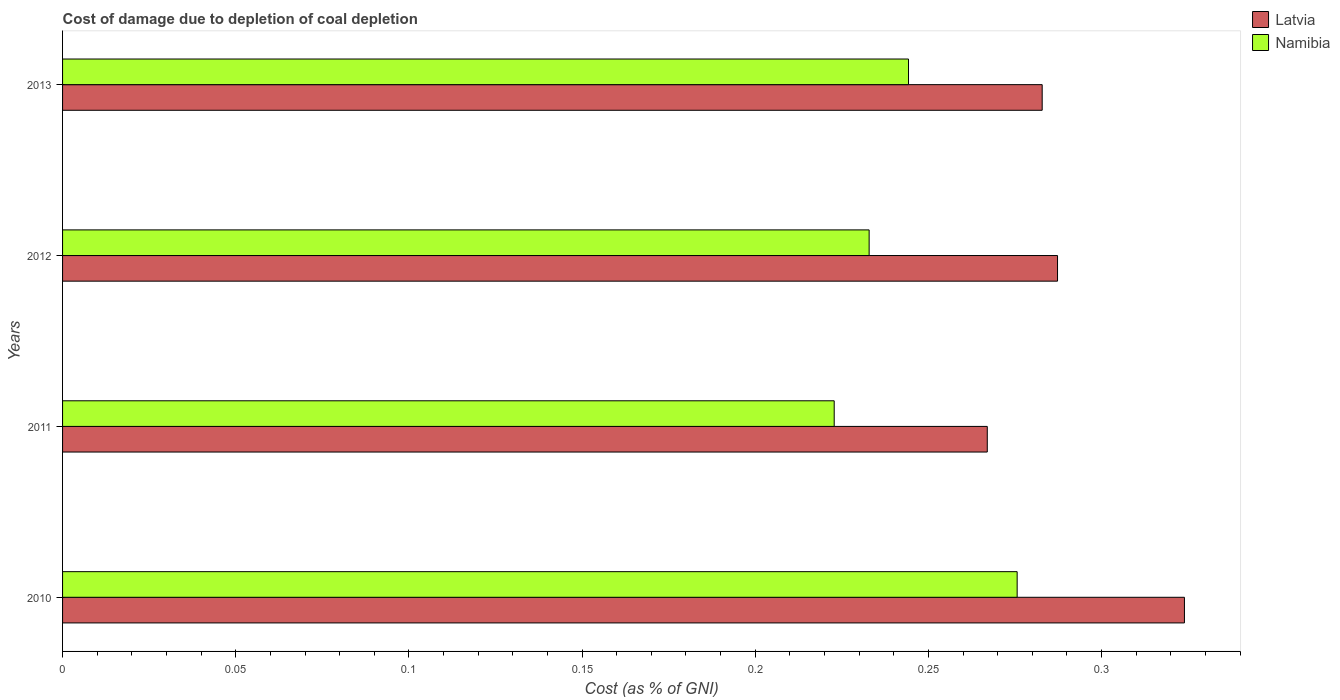How many groups of bars are there?
Your answer should be very brief. 4. Are the number of bars per tick equal to the number of legend labels?
Offer a very short reply. Yes. Are the number of bars on each tick of the Y-axis equal?
Keep it short and to the point. Yes. How many bars are there on the 3rd tick from the bottom?
Your answer should be compact. 2. What is the label of the 2nd group of bars from the top?
Your response must be concise. 2012. What is the cost of damage caused due to coal depletion in Latvia in 2011?
Make the answer very short. 0.27. Across all years, what is the maximum cost of damage caused due to coal depletion in Namibia?
Provide a short and direct response. 0.28. Across all years, what is the minimum cost of damage caused due to coal depletion in Latvia?
Your answer should be compact. 0.27. In which year was the cost of damage caused due to coal depletion in Latvia minimum?
Make the answer very short. 2011. What is the total cost of damage caused due to coal depletion in Namibia in the graph?
Provide a succinct answer. 0.98. What is the difference between the cost of damage caused due to coal depletion in Namibia in 2012 and that in 2013?
Offer a terse response. -0.01. What is the difference between the cost of damage caused due to coal depletion in Latvia in 2013 and the cost of damage caused due to coal depletion in Namibia in 2012?
Provide a succinct answer. 0.05. What is the average cost of damage caused due to coal depletion in Namibia per year?
Give a very brief answer. 0.24. In the year 2013, what is the difference between the cost of damage caused due to coal depletion in Latvia and cost of damage caused due to coal depletion in Namibia?
Your response must be concise. 0.04. In how many years, is the cost of damage caused due to coal depletion in Namibia greater than 0.16000000000000003 %?
Offer a very short reply. 4. What is the ratio of the cost of damage caused due to coal depletion in Latvia in 2012 to that in 2013?
Keep it short and to the point. 1.02. Is the difference between the cost of damage caused due to coal depletion in Latvia in 2012 and 2013 greater than the difference between the cost of damage caused due to coal depletion in Namibia in 2012 and 2013?
Offer a terse response. Yes. What is the difference between the highest and the second highest cost of damage caused due to coal depletion in Namibia?
Offer a very short reply. 0.03. What is the difference between the highest and the lowest cost of damage caused due to coal depletion in Latvia?
Your answer should be compact. 0.06. In how many years, is the cost of damage caused due to coal depletion in Latvia greater than the average cost of damage caused due to coal depletion in Latvia taken over all years?
Provide a succinct answer. 1. Is the sum of the cost of damage caused due to coal depletion in Namibia in 2010 and 2012 greater than the maximum cost of damage caused due to coal depletion in Latvia across all years?
Offer a very short reply. Yes. What does the 1st bar from the top in 2010 represents?
Give a very brief answer. Namibia. What does the 1st bar from the bottom in 2013 represents?
Ensure brevity in your answer.  Latvia. Are all the bars in the graph horizontal?
Give a very brief answer. Yes. Does the graph contain any zero values?
Provide a succinct answer. No. Where does the legend appear in the graph?
Provide a succinct answer. Top right. How many legend labels are there?
Make the answer very short. 2. How are the legend labels stacked?
Provide a succinct answer. Vertical. What is the title of the graph?
Provide a short and direct response. Cost of damage due to depletion of coal depletion. What is the label or title of the X-axis?
Ensure brevity in your answer.  Cost (as % of GNI). What is the Cost (as % of GNI) in Latvia in 2010?
Provide a succinct answer. 0.32. What is the Cost (as % of GNI) of Namibia in 2010?
Ensure brevity in your answer.  0.28. What is the Cost (as % of GNI) of Latvia in 2011?
Offer a very short reply. 0.27. What is the Cost (as % of GNI) of Namibia in 2011?
Keep it short and to the point. 0.22. What is the Cost (as % of GNI) of Latvia in 2012?
Provide a short and direct response. 0.29. What is the Cost (as % of GNI) of Namibia in 2012?
Give a very brief answer. 0.23. What is the Cost (as % of GNI) of Latvia in 2013?
Your response must be concise. 0.28. What is the Cost (as % of GNI) in Namibia in 2013?
Provide a short and direct response. 0.24. Across all years, what is the maximum Cost (as % of GNI) in Latvia?
Your answer should be very brief. 0.32. Across all years, what is the maximum Cost (as % of GNI) in Namibia?
Keep it short and to the point. 0.28. Across all years, what is the minimum Cost (as % of GNI) of Latvia?
Provide a short and direct response. 0.27. Across all years, what is the minimum Cost (as % of GNI) in Namibia?
Your response must be concise. 0.22. What is the total Cost (as % of GNI) of Latvia in the graph?
Make the answer very short. 1.16. What is the total Cost (as % of GNI) of Namibia in the graph?
Provide a short and direct response. 0.98. What is the difference between the Cost (as % of GNI) in Latvia in 2010 and that in 2011?
Provide a short and direct response. 0.06. What is the difference between the Cost (as % of GNI) in Namibia in 2010 and that in 2011?
Offer a very short reply. 0.05. What is the difference between the Cost (as % of GNI) of Latvia in 2010 and that in 2012?
Ensure brevity in your answer.  0.04. What is the difference between the Cost (as % of GNI) in Namibia in 2010 and that in 2012?
Your response must be concise. 0.04. What is the difference between the Cost (as % of GNI) of Latvia in 2010 and that in 2013?
Your answer should be very brief. 0.04. What is the difference between the Cost (as % of GNI) in Namibia in 2010 and that in 2013?
Your answer should be compact. 0.03. What is the difference between the Cost (as % of GNI) in Latvia in 2011 and that in 2012?
Make the answer very short. -0.02. What is the difference between the Cost (as % of GNI) of Namibia in 2011 and that in 2012?
Your answer should be compact. -0.01. What is the difference between the Cost (as % of GNI) in Latvia in 2011 and that in 2013?
Keep it short and to the point. -0.02. What is the difference between the Cost (as % of GNI) of Namibia in 2011 and that in 2013?
Keep it short and to the point. -0.02. What is the difference between the Cost (as % of GNI) in Latvia in 2012 and that in 2013?
Make the answer very short. 0. What is the difference between the Cost (as % of GNI) of Namibia in 2012 and that in 2013?
Your answer should be compact. -0.01. What is the difference between the Cost (as % of GNI) of Latvia in 2010 and the Cost (as % of GNI) of Namibia in 2011?
Ensure brevity in your answer.  0.1. What is the difference between the Cost (as % of GNI) of Latvia in 2010 and the Cost (as % of GNI) of Namibia in 2012?
Provide a short and direct response. 0.09. What is the difference between the Cost (as % of GNI) of Latvia in 2010 and the Cost (as % of GNI) of Namibia in 2013?
Offer a terse response. 0.08. What is the difference between the Cost (as % of GNI) of Latvia in 2011 and the Cost (as % of GNI) of Namibia in 2012?
Give a very brief answer. 0.03. What is the difference between the Cost (as % of GNI) of Latvia in 2011 and the Cost (as % of GNI) of Namibia in 2013?
Provide a succinct answer. 0.02. What is the difference between the Cost (as % of GNI) in Latvia in 2012 and the Cost (as % of GNI) in Namibia in 2013?
Offer a terse response. 0.04. What is the average Cost (as % of GNI) in Latvia per year?
Ensure brevity in your answer.  0.29. What is the average Cost (as % of GNI) in Namibia per year?
Provide a short and direct response. 0.24. In the year 2010, what is the difference between the Cost (as % of GNI) in Latvia and Cost (as % of GNI) in Namibia?
Provide a short and direct response. 0.05. In the year 2011, what is the difference between the Cost (as % of GNI) in Latvia and Cost (as % of GNI) in Namibia?
Your response must be concise. 0.04. In the year 2012, what is the difference between the Cost (as % of GNI) in Latvia and Cost (as % of GNI) in Namibia?
Offer a terse response. 0.05. In the year 2013, what is the difference between the Cost (as % of GNI) in Latvia and Cost (as % of GNI) in Namibia?
Make the answer very short. 0.04. What is the ratio of the Cost (as % of GNI) in Latvia in 2010 to that in 2011?
Your answer should be very brief. 1.21. What is the ratio of the Cost (as % of GNI) of Namibia in 2010 to that in 2011?
Your response must be concise. 1.24. What is the ratio of the Cost (as % of GNI) of Latvia in 2010 to that in 2012?
Your answer should be compact. 1.13. What is the ratio of the Cost (as % of GNI) of Namibia in 2010 to that in 2012?
Your response must be concise. 1.18. What is the ratio of the Cost (as % of GNI) in Latvia in 2010 to that in 2013?
Keep it short and to the point. 1.15. What is the ratio of the Cost (as % of GNI) in Namibia in 2010 to that in 2013?
Offer a terse response. 1.13. What is the ratio of the Cost (as % of GNI) in Latvia in 2011 to that in 2012?
Offer a very short reply. 0.93. What is the ratio of the Cost (as % of GNI) in Namibia in 2011 to that in 2012?
Make the answer very short. 0.96. What is the ratio of the Cost (as % of GNI) of Latvia in 2011 to that in 2013?
Keep it short and to the point. 0.94. What is the ratio of the Cost (as % of GNI) of Namibia in 2011 to that in 2013?
Keep it short and to the point. 0.91. What is the ratio of the Cost (as % of GNI) in Latvia in 2012 to that in 2013?
Keep it short and to the point. 1.02. What is the ratio of the Cost (as % of GNI) in Namibia in 2012 to that in 2013?
Provide a succinct answer. 0.95. What is the difference between the highest and the second highest Cost (as % of GNI) of Latvia?
Give a very brief answer. 0.04. What is the difference between the highest and the second highest Cost (as % of GNI) in Namibia?
Make the answer very short. 0.03. What is the difference between the highest and the lowest Cost (as % of GNI) in Latvia?
Keep it short and to the point. 0.06. What is the difference between the highest and the lowest Cost (as % of GNI) of Namibia?
Provide a short and direct response. 0.05. 